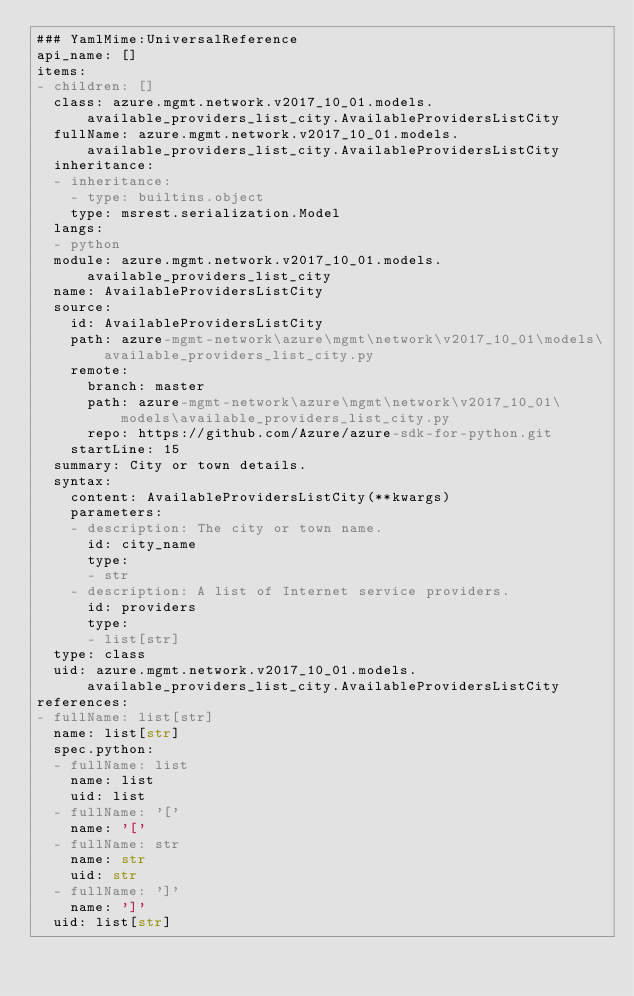Convert code to text. <code><loc_0><loc_0><loc_500><loc_500><_YAML_>### YamlMime:UniversalReference
api_name: []
items:
- children: []
  class: azure.mgmt.network.v2017_10_01.models.available_providers_list_city.AvailableProvidersListCity
  fullName: azure.mgmt.network.v2017_10_01.models.available_providers_list_city.AvailableProvidersListCity
  inheritance:
  - inheritance:
    - type: builtins.object
    type: msrest.serialization.Model
  langs:
  - python
  module: azure.mgmt.network.v2017_10_01.models.available_providers_list_city
  name: AvailableProvidersListCity
  source:
    id: AvailableProvidersListCity
    path: azure-mgmt-network\azure\mgmt\network\v2017_10_01\models\available_providers_list_city.py
    remote:
      branch: master
      path: azure-mgmt-network\azure\mgmt\network\v2017_10_01\models\available_providers_list_city.py
      repo: https://github.com/Azure/azure-sdk-for-python.git
    startLine: 15
  summary: City or town details.
  syntax:
    content: AvailableProvidersListCity(**kwargs)
    parameters:
    - description: The city or town name.
      id: city_name
      type:
      - str
    - description: A list of Internet service providers.
      id: providers
      type:
      - list[str]
  type: class
  uid: azure.mgmt.network.v2017_10_01.models.available_providers_list_city.AvailableProvidersListCity
references:
- fullName: list[str]
  name: list[str]
  spec.python:
  - fullName: list
    name: list
    uid: list
  - fullName: '['
    name: '['
  - fullName: str
    name: str
    uid: str
  - fullName: ']'
    name: ']'
  uid: list[str]
</code> 